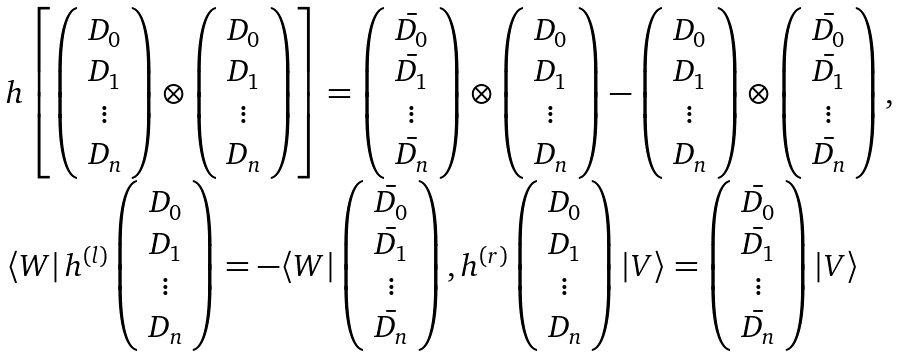<formula> <loc_0><loc_0><loc_500><loc_500>\begin{array} { l } h \left [ \left ( \begin{array} { c } D _ { 0 } \\ D _ { 1 } \\ \vdots \\ D _ { n } \end{array} \right ) \otimes \left ( \begin{array} { c } D _ { 0 } \\ D _ { 1 } \\ \vdots \\ D _ { n } \end{array} \right ) \right ] = \left ( \begin{array} { c } \bar { D _ { 0 } } \\ \bar { D _ { 1 } } \\ \vdots \\ \bar { D _ { n } } \end{array} \right ) \otimes \left ( \begin{array} { c } D _ { 0 } \\ D _ { 1 } \\ \vdots \\ D _ { n } \end{array} \right ) - \left ( \begin{array} { c } D _ { 0 } \\ D _ { 1 } \\ \vdots \\ D _ { n } \end{array} \right ) \otimes \left ( \begin{array} { c } \bar { D _ { 0 } } \\ \bar { D _ { 1 } } \\ \vdots \\ \bar { D _ { n } } \end{array} \right ) , \\ \langle W | \, h ^ { ( l ) } \left ( \begin{array} { c } D _ { 0 } \\ D _ { 1 } \\ \vdots \\ D _ { n } \end{array} \right ) = - \langle W | \left ( \begin{array} { c } \bar { D _ { 0 } } \\ \bar { D _ { 1 } } \\ \vdots \\ \bar { D _ { n } } \end{array} \right ) , h ^ { ( r ) } \left ( \begin{array} { c } D _ { 0 } \\ D _ { 1 } \\ \vdots \\ D _ { n } \end{array} \right ) | V \rangle = \left ( \begin{array} { c } \bar { D _ { 0 } } \\ \bar { D _ { 1 } } \\ \vdots \\ \bar { D _ { n } } \end{array} \right ) | V \rangle \end{array}</formula> 